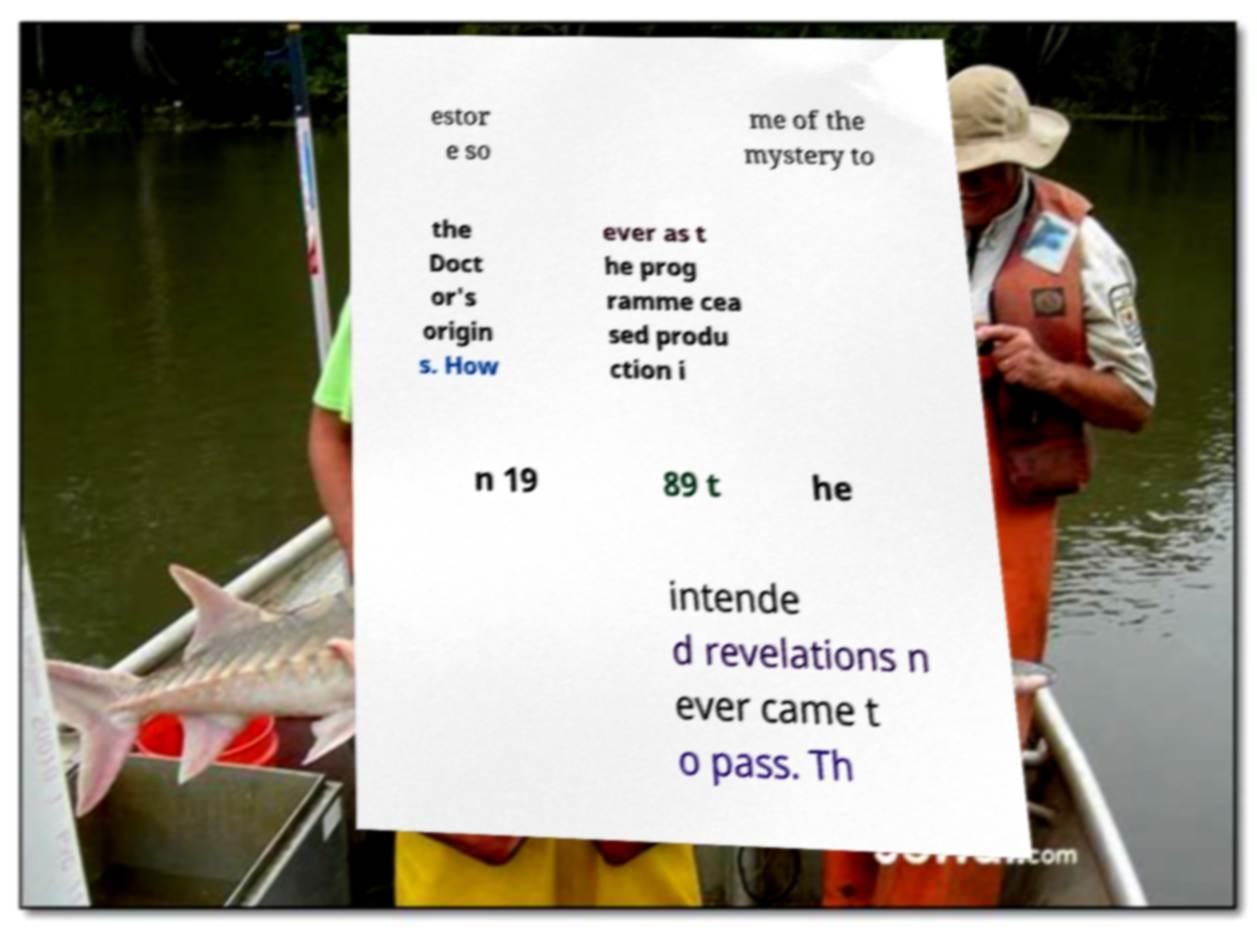Could you assist in decoding the text presented in this image and type it out clearly? estor e so me of the mystery to the Doct or's origin s. How ever as t he prog ramme cea sed produ ction i n 19 89 t he intende d revelations n ever came t o pass. Th 